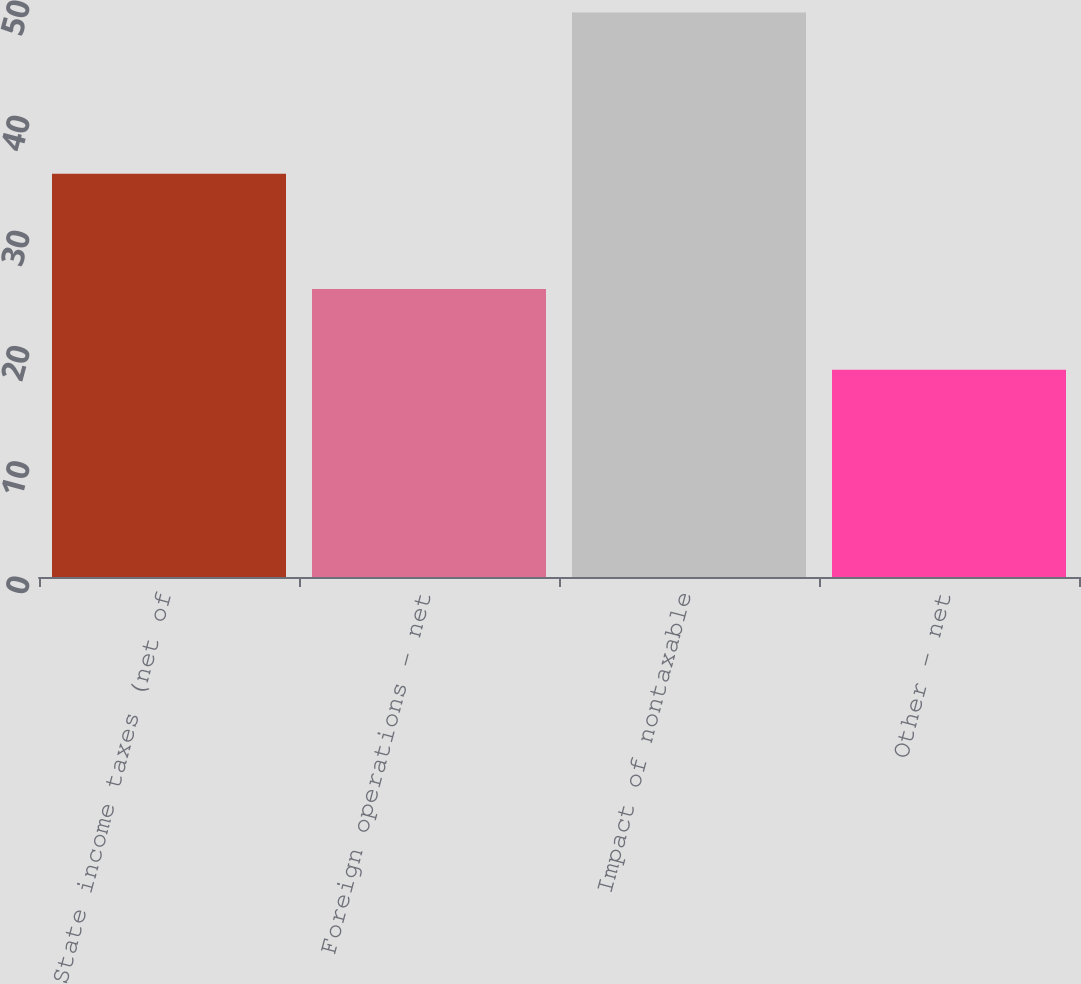Convert chart. <chart><loc_0><loc_0><loc_500><loc_500><bar_chart><fcel>State income taxes (net of<fcel>Foreign operations - net<fcel>Impact of nontaxable<fcel>Other - net<nl><fcel>35<fcel>25<fcel>49<fcel>18<nl></chart> 